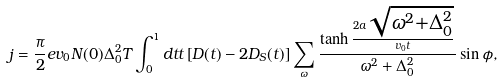Convert formula to latex. <formula><loc_0><loc_0><loc_500><loc_500>j = \frac { \pi } { 2 } e v _ { 0 } N ( 0 ) \Delta _ { 0 } ^ { 2 } T \int _ { 0 } ^ { 1 } d t t \left [ D ( t ) - 2 D _ { S } ( t ) \right ] \sum _ { \omega } \frac { \tanh \frac { 2 a \sqrt { \omega ^ { 2 } + \Delta _ { 0 } ^ { 2 } } } { v _ { 0 } t } } { \omega ^ { 2 } + \Delta _ { 0 } ^ { 2 } } \sin \phi ,</formula> 